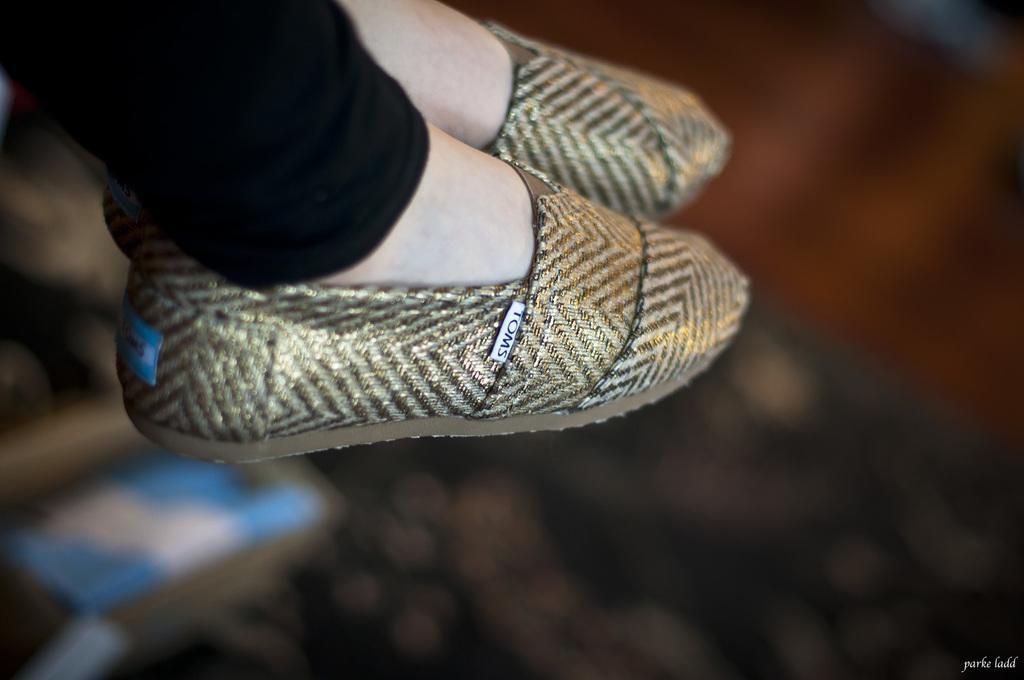In one or two sentences, can you explain what this image depicts? In this image a person's legs are visible. He is wearing footwear. Background is blurry. 